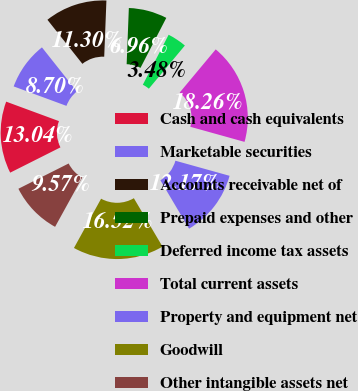Convert chart. <chart><loc_0><loc_0><loc_500><loc_500><pie_chart><fcel>Cash and cash equivalents<fcel>Marketable securities<fcel>Accounts receivable net of<fcel>Prepaid expenses and other<fcel>Deferred income tax assets<fcel>Total current assets<fcel>Property and equipment net<fcel>Goodwill<fcel>Other intangible assets net<nl><fcel>13.04%<fcel>8.7%<fcel>11.3%<fcel>6.96%<fcel>3.48%<fcel>18.26%<fcel>12.17%<fcel>16.52%<fcel>9.57%<nl></chart> 